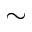Convert formula to latex. <formula><loc_0><loc_0><loc_500><loc_500>\sim</formula> 